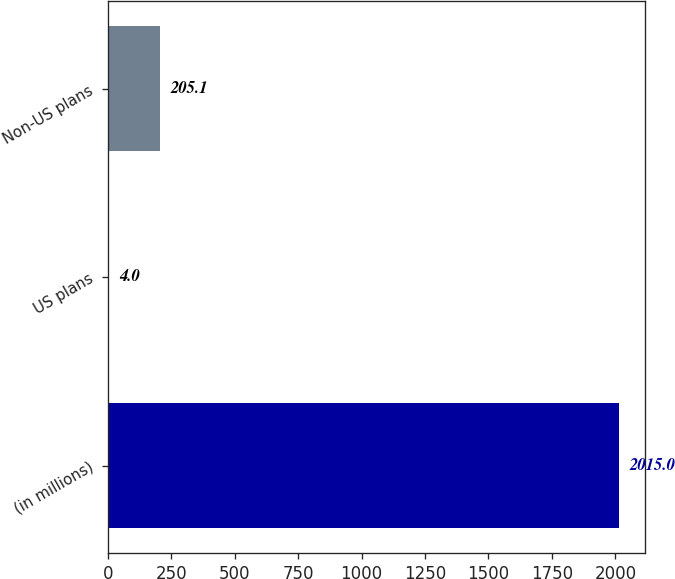Convert chart. <chart><loc_0><loc_0><loc_500><loc_500><bar_chart><fcel>(in millions)<fcel>US plans<fcel>Non-US plans<nl><fcel>2015<fcel>4<fcel>205.1<nl></chart> 